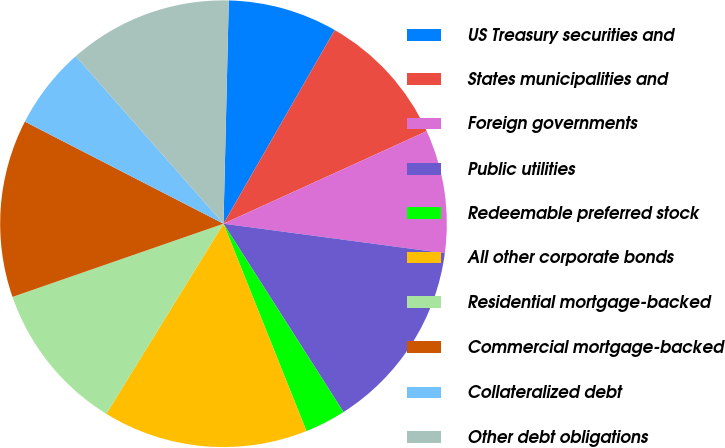Convert chart to OTSL. <chart><loc_0><loc_0><loc_500><loc_500><pie_chart><fcel>US Treasury securities and<fcel>States municipalities and<fcel>Foreign governments<fcel>Public utilities<fcel>Redeemable preferred stock<fcel>All other corporate bonds<fcel>Residential mortgage-backed<fcel>Commercial mortgage-backed<fcel>Collateralized debt<fcel>Other debt obligations<nl><fcel>7.92%<fcel>9.9%<fcel>8.91%<fcel>13.86%<fcel>2.97%<fcel>14.85%<fcel>10.89%<fcel>12.87%<fcel>5.94%<fcel>11.88%<nl></chart> 